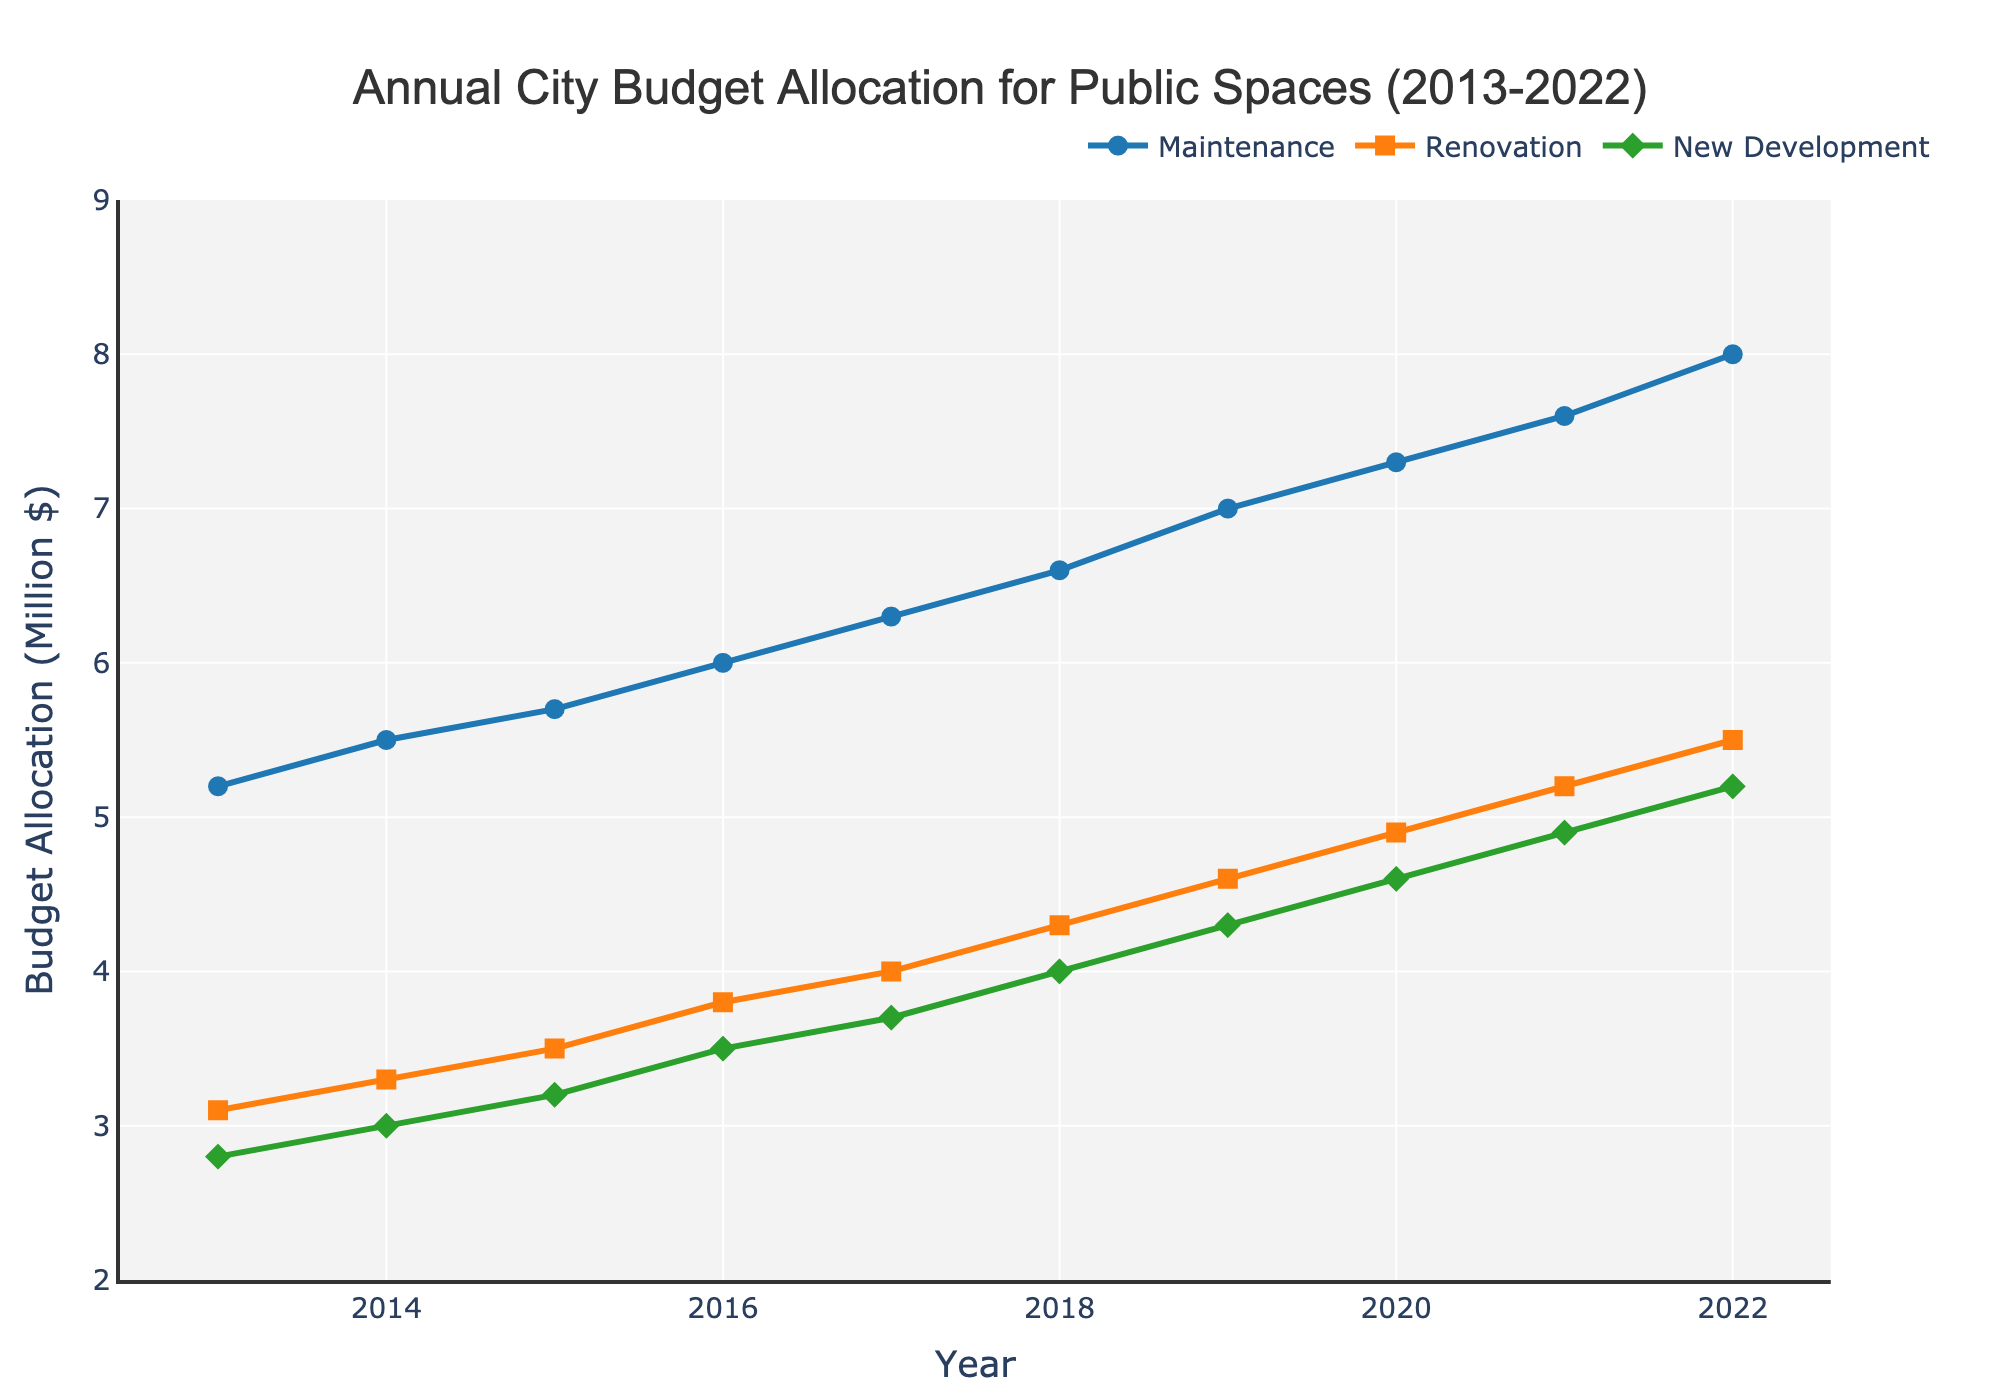How does the budget allocation for New Development change over the years 2013-2022? To answer this question, observe the green line representing New Development. It shows a steady increase from $2.8 million in 2013 to $5.2 million in 2022.
Answer: The budget allocation for New Development increases What category had the highest budget allocation in 2020? By looking at the values for 2020, Maintenance is allocated $7.3 million, Renovation $4.9 million, and New Development $4.6 million. Therefore, Maintenance has the highest budget allocation.
Answer: Maintenance Between which years did the Maintenance budget see the largest increase? To find this, compare the yearly differences. Maintenance increased from $6.6 million to $7.0 million from 2018 to 2019, which is $0.4 million, the largest observed increase.
Answer: 2018-2019 What is the total budget allocation for Renovation over the decade? Sum the yearly allocations for Renovation: 3.1 + 3.3 + 3.5 + 3.8 + 4.0 + 4.3 + 4.6 + 4.9 + 5.2 + 5.5 = 41.2 million.
Answer: 41.2 million Compare the budget allocations for Maintenance and New Development in 2015. Which one is higher and by how much? In 2015, Maintenance is $5.7 million and New Development is $3.2 million. Maintenance is higher by $5.7 - $3.2 = $2.5 million.
Answer: Maintenance is higher by $2.5 million What is the average annual budget allocation for Renovation over the decade? Sum the yearly Renovation allocations and divide by 10: (3.1 + 3.3 + 3.5 + 3.8 + 4.0 + 4.3 + 4.6 + 4.9 + 5.2 + 5.5) / 10 = 4.12 million.
Answer: 4.12 million Which year experienced the smallest increase in the total budget allocation for all three categories compared to the previous year? Calculate the total budget for each year and find the year with the smallest increase: smallest increase occurs between 2014 and 2015; respective totals are 11.3 (2014) and 12.4 (2015), increase of 1.1 million.
Answer: 2013-2014 How does the Renovation budget trend compare to the Maintenance budget trend from 2013 to 2022? Both trends show an increase over time, with Maintenance rising steadily from $5.2 million to $8.0 million, and Renovation from $3.1 million to $5.5 million. However, the increase in Maintenance is more pronounced.
Answer: Both increase, Maintenance rises more significantly What was the budget allocation for Maintenance relative to the total budget for public spaces in 2019? In 2019, the Maintenance budget is $7.0 million. The total budget for that year is 7.0 (Maintenance) + 4.6 (Renovation) + 4.3 (New Development) = 15.9 million. Therefore, the relative allocation for Maintenance is (7.0 / 15.9) * 100 ≈ 44%.
Answer: Approximately 44% What is the difference in the budget allocation between the highest and lowest categories in 2022? In 2022, Maintenance is $8.0 million, Renovation is $5.5 million, and New Development is $5.2 million. The difference between Maintenance (highest) and New Development (lowest) is $8.0 - $5.2 = $2.8 million.
Answer: $2.8 million 